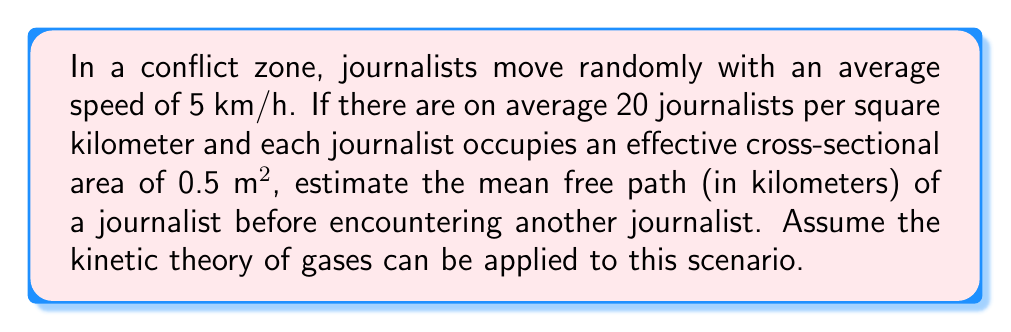Could you help me with this problem? To solve this problem, we'll use the kinetic theory of gases and apply it to journalists in a high-risk reporting environment. The mean free path formula is:

$$\lambda = \frac{1}{n\sigma\sqrt{2}}$$

Where:
$\lambda$ = mean free path
$n$ = number density of journalists
$\sigma$ = effective cross-sectional area of a journalist

Step 1: Calculate the number density (n)
Given: 20 journalists per km²
Convert to journalists per m²:
$n = \frac{20 \text{ journalists}}{1 \text{ km}^2} \times \frac{1 \text{ km}^2}{1,000,000 \text{ m}^2} = 2 \times 10^{-5} \text{ journalists/m}^2$

Step 2: Convert the cross-sectional area (σ) to m²
$\sigma = 0.5 \text{ m}^2$

Step 3: Apply the mean free path formula
$$\lambda = \frac{1}{(2 \times 10^{-5} \text{ journalists/m}^2)(0.5 \text{ m}^2)\sqrt{2}}$$

Step 4: Calculate the result
$$\lambda = \frac{1}{1 \times 10^{-5} \sqrt{2}} \text{ m} \approx 70,710 \text{ m}$$

Step 5: Convert the result to kilometers
$$\lambda \approx 70,710 \text{ m} \times \frac{1 \text{ km}}{1000 \text{ m}} \approx 70.71 \text{ km}$$

Therefore, the estimated mean free path of a journalist in this high-risk reporting environment is approximately 70.71 km.
Answer: 70.71 km 